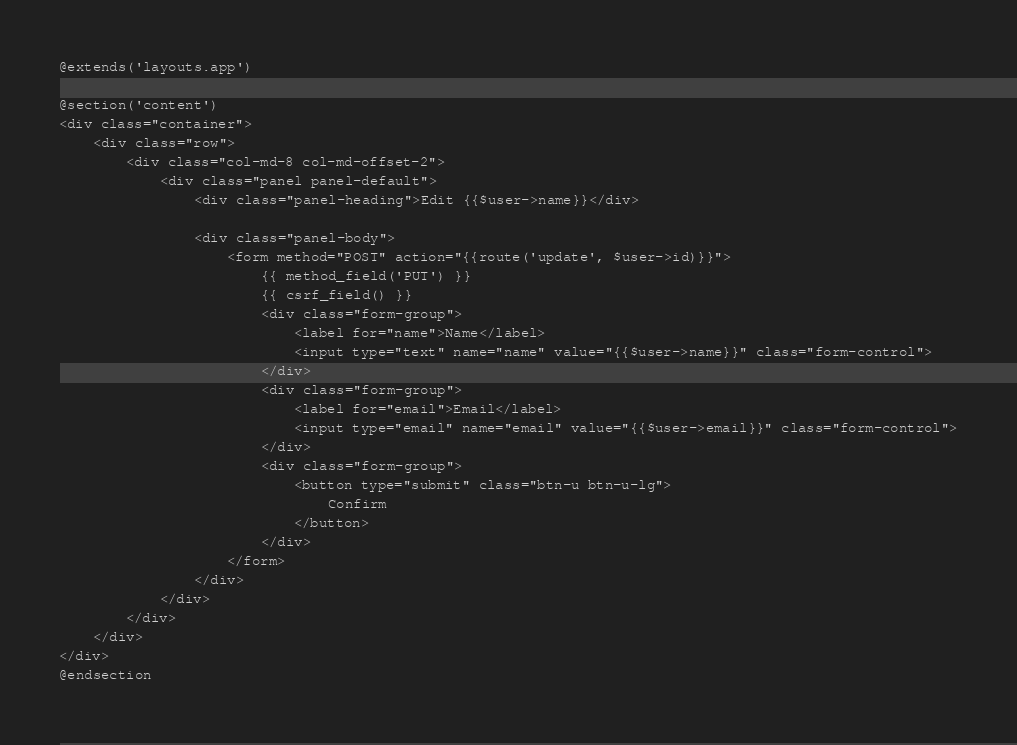Convert code to text. <code><loc_0><loc_0><loc_500><loc_500><_PHP_>@extends('layouts.app')

@section('content')
<div class="container">
    <div class="row">
        <div class="col-md-8 col-md-offset-2">
            <div class="panel panel-default">
                <div class="panel-heading">Edit {{$user->name}}</div>

                <div class="panel-body">
					<form method="POST" action="{{route('update', $user->id)}}">
						{{ method_field('PUT') }}
						{{ csrf_field() }}
						<div class="form-group">
							<label for="name">Name</label>
							<input type="text" name="name" value="{{$user->name}}" class="form-control">
						</div>
						<div class="form-group">
							<label for="email">Email</label>
							<input type="email" name="email" value="{{$user->email}}" class="form-control">
						</div>
						<div class="form-group">
					        <button type="submit" class="btn-u btn-u-lg">
					            Confirm
					        </button>
						</div>
					</form>
                </div>
            </div>
        </div>
    </div>
</div>
@endsection</code> 